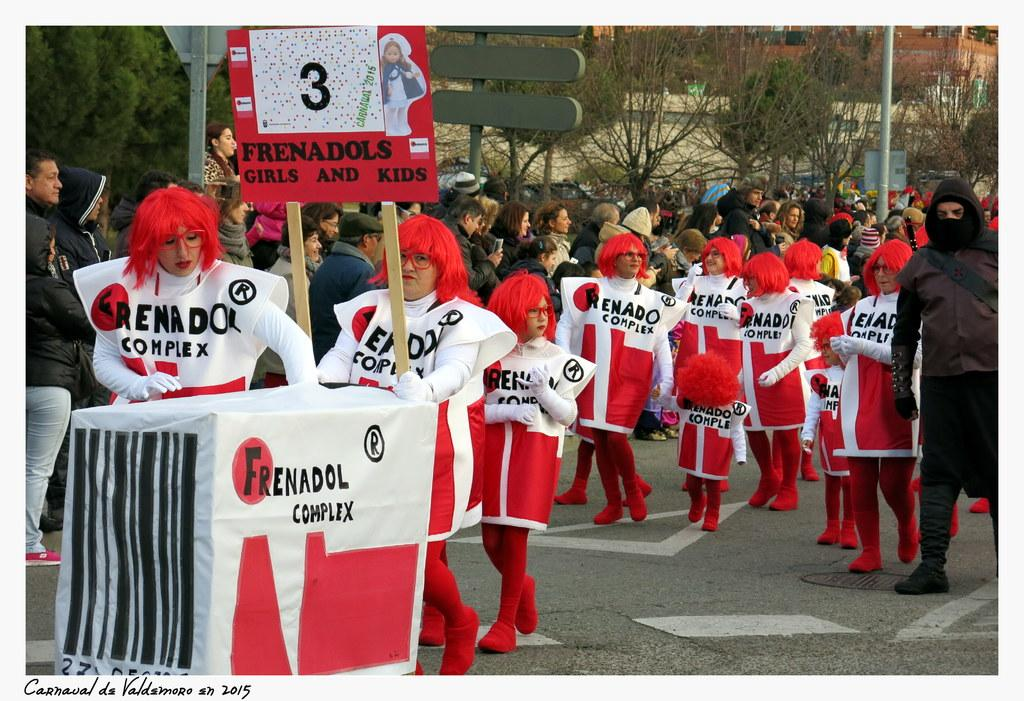Provide a one-sentence caption for the provided image. People dresed in red and white, one of whom is carrying a placard with the number 3. 